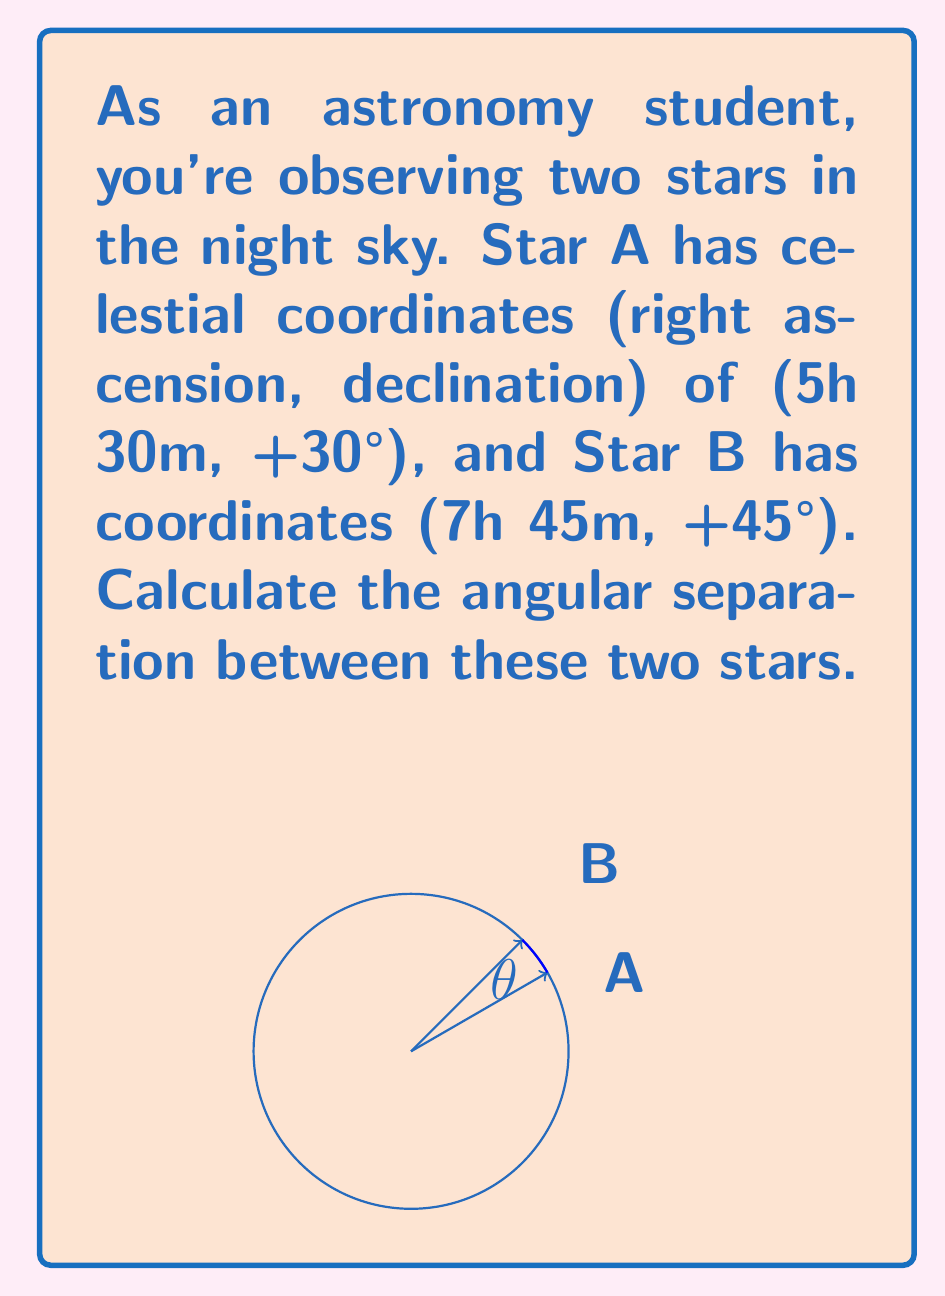Provide a solution to this math problem. To find the angular separation between two celestial objects, we can use the spherical law of cosines:

$$\cos(\theta) = \sin(\delta_1)\sin(\delta_2) + \cos(\delta_1)\cos(\delta_2)\cos(\Delta\alpha)$$

Where:
- $\theta$ is the angular separation
- $\delta_1$ and $\delta_2$ are the declinations of the two objects
- $\Delta\alpha$ is the difference in right ascension

Step 1: Convert all angles to degrees.
- Star A: RA = 5h 30m = 5.5h * 15°/h = 82.5°, Dec = 30°
- Star B: RA = 7h 45m = 7.75h * 15°/h = 116.25°, Dec = 45°

Step 2: Calculate $\Delta\alpha$
$\Delta\alpha = 116.25° - 82.5° = 33.75°$

Step 3: Apply the spherical law of cosines
$$\cos(\theta) = \sin(30°)\sin(45°) + \cos(30°)\cos(45°)\cos(33.75°)$$

Step 4: Calculate the result
$$\cos(\theta) = 0.5 * 0.7071 + 0.8660 * 0.7071 * 0.8321 = 0.9397$$

Step 5: Take the inverse cosine (arccos) to find $\theta$
$$\theta = \arccos(0.9397) = 20.1°$$

Therefore, the angular separation between the two stars is approximately 20.1°.
Answer: 20.1° 